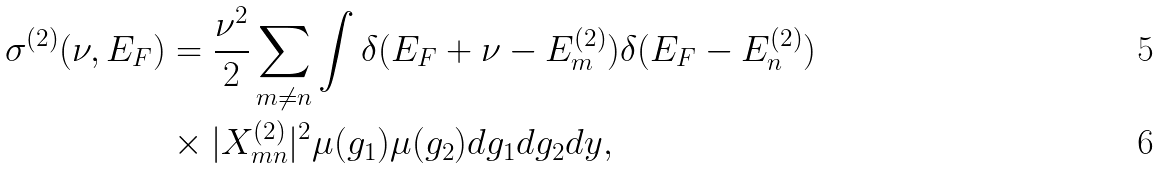<formula> <loc_0><loc_0><loc_500><loc_500>\sigma ^ { ( 2 ) } ( \nu , E _ { F } ) & = \frac { \nu ^ { 2 } } { 2 } \sum _ { m \neq n } \int \delta ( E _ { F } + \nu - E _ { m } ^ { ( 2 ) } ) \delta ( E _ { F } - E _ { n } ^ { ( 2 ) } ) \\ & \times | X _ { m n } ^ { ( 2 ) } | ^ { 2 } \mu ( g _ { 1 } ) \mu ( g _ { 2 } ) d g _ { 1 } d g _ { 2 } d y ,</formula> 